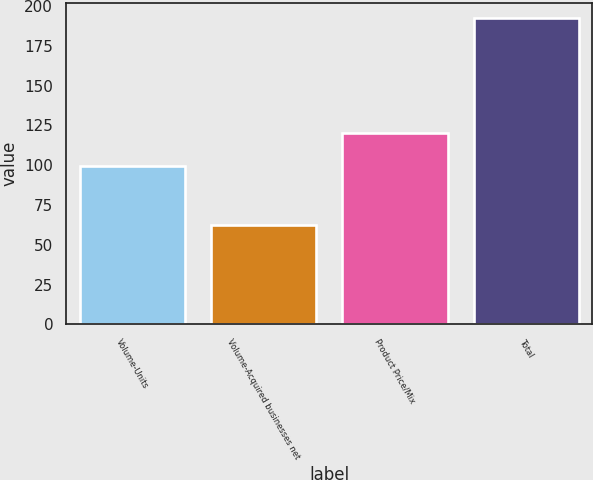<chart> <loc_0><loc_0><loc_500><loc_500><bar_chart><fcel>Volume-Units<fcel>Volume-Acquired businesses net<fcel>Product Price/Mix<fcel>Total<nl><fcel>99.5<fcel>62.1<fcel>120.1<fcel>192.3<nl></chart> 